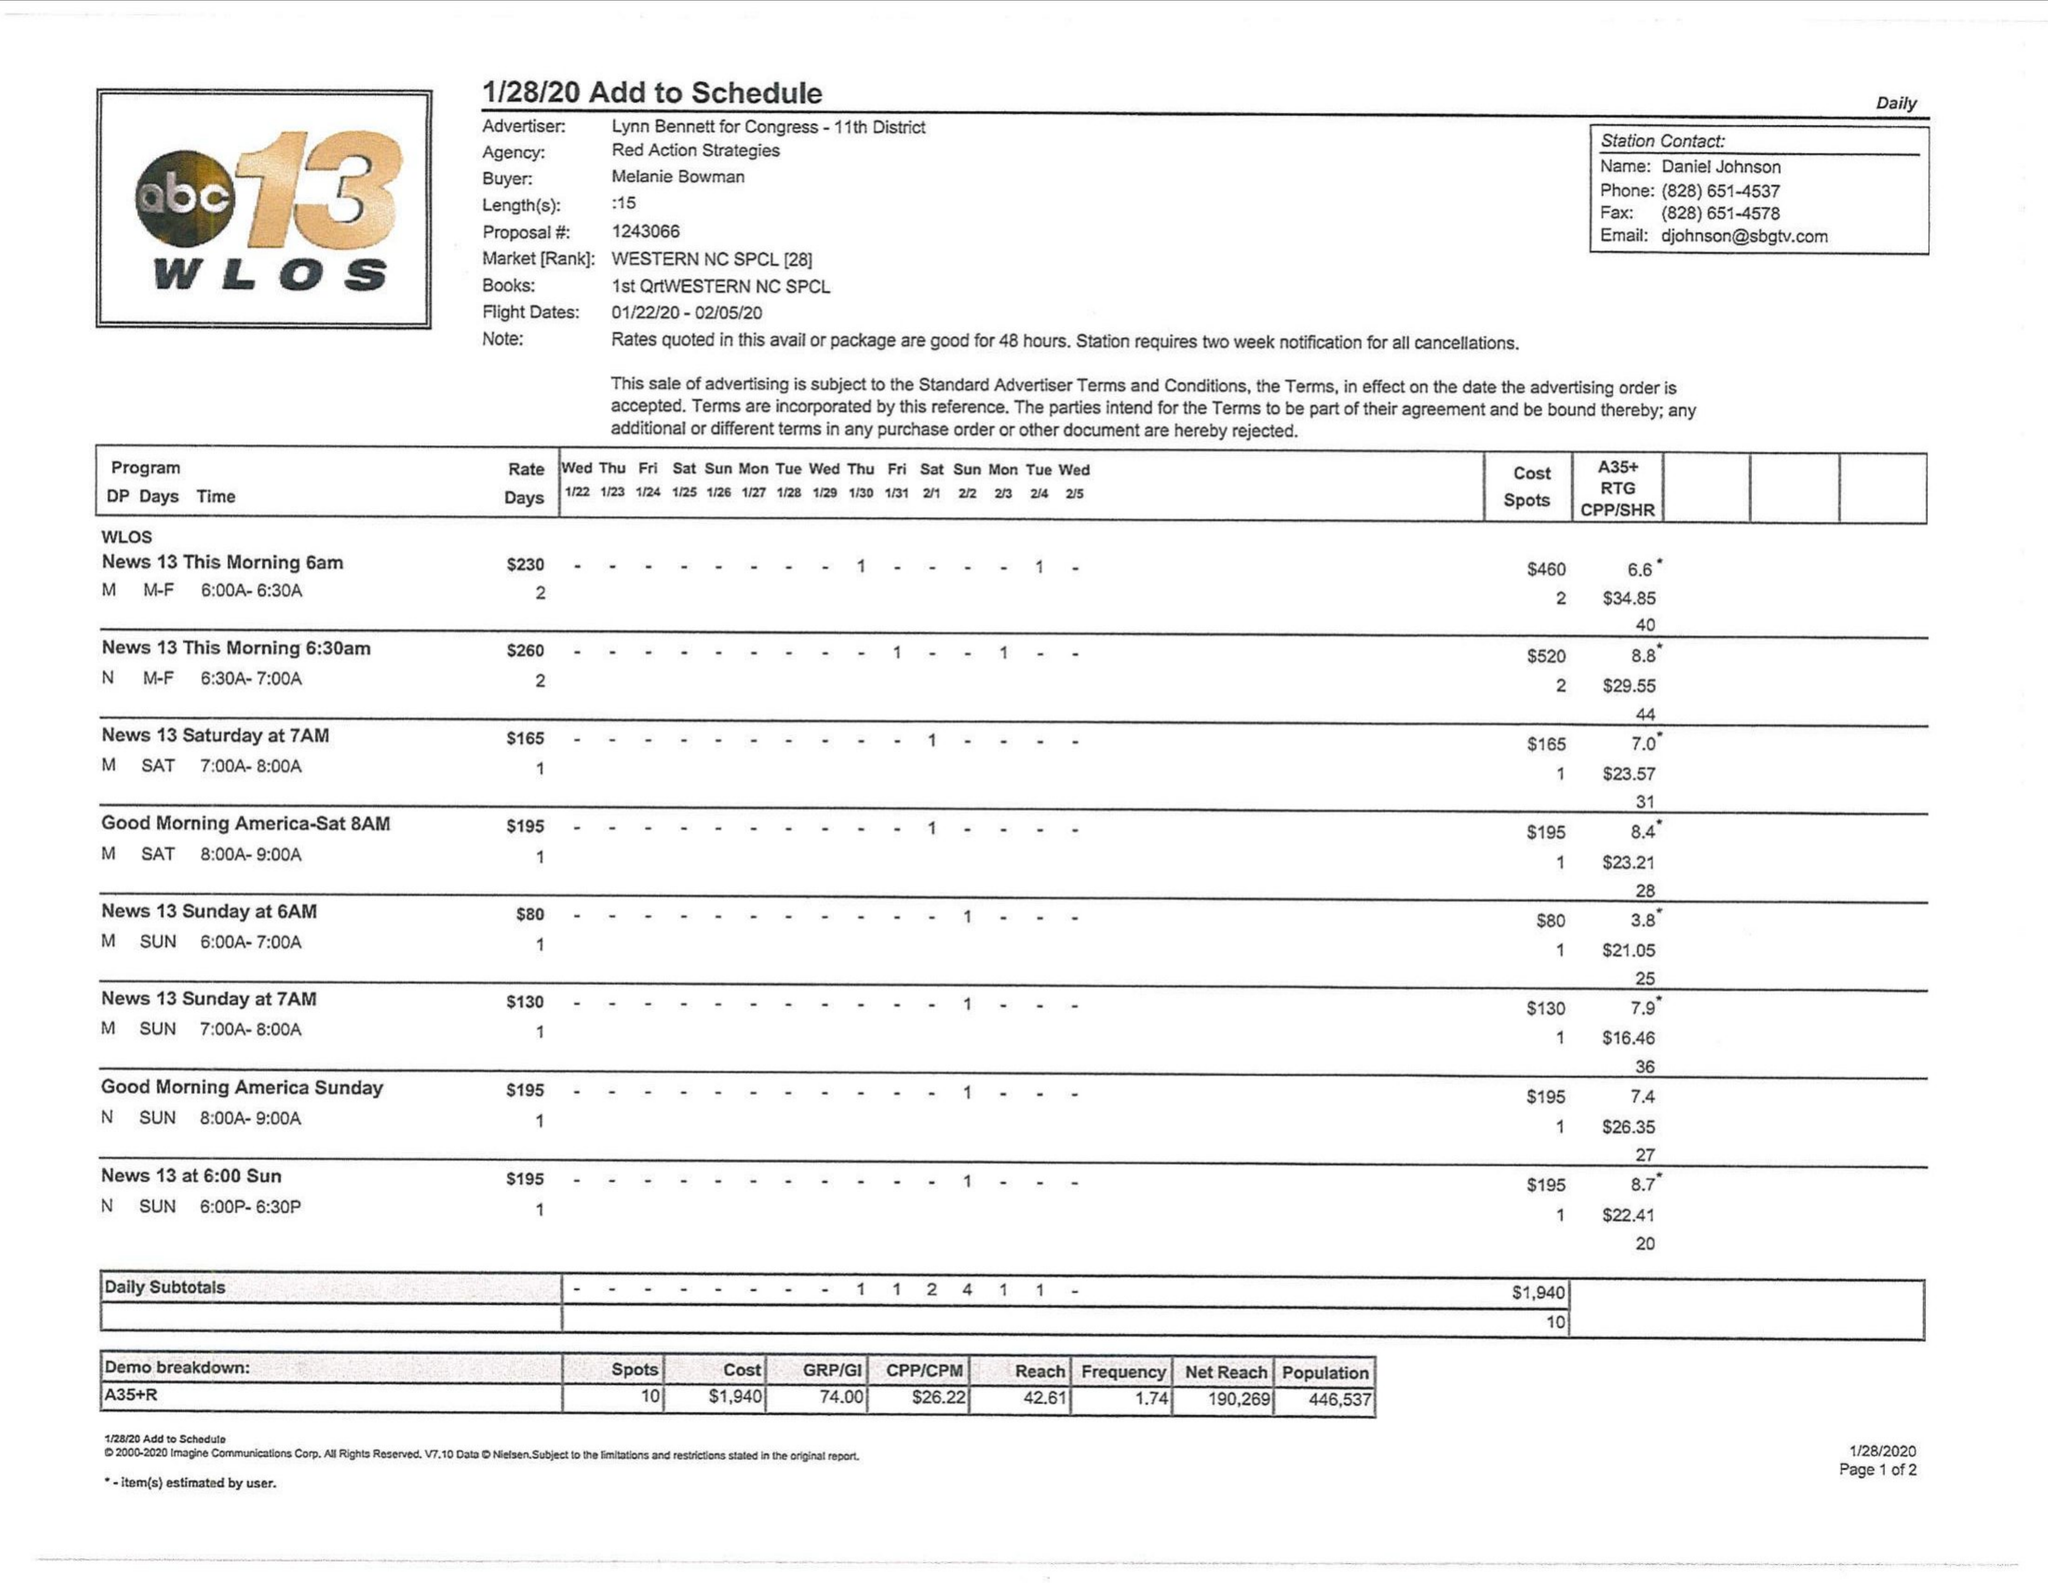What is the value for the contract_num?
Answer the question using a single word or phrase. 1243066 